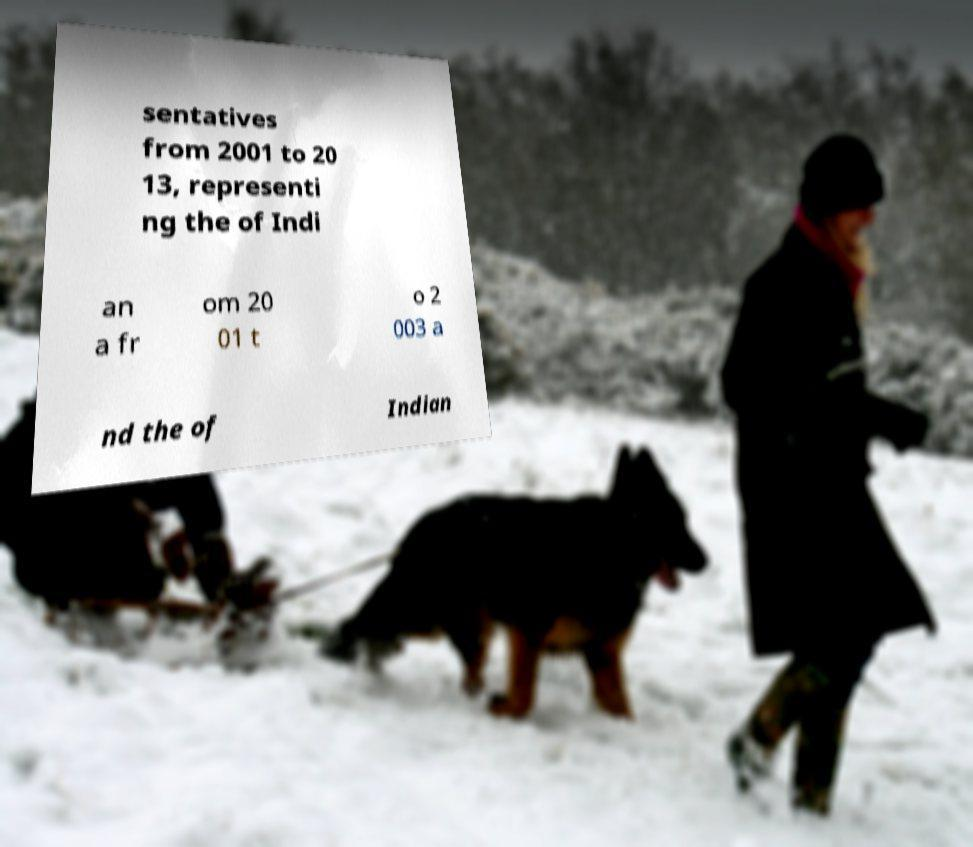Could you extract and type out the text from this image? sentatives from 2001 to 20 13, representi ng the of Indi an a fr om 20 01 t o 2 003 a nd the of Indian 